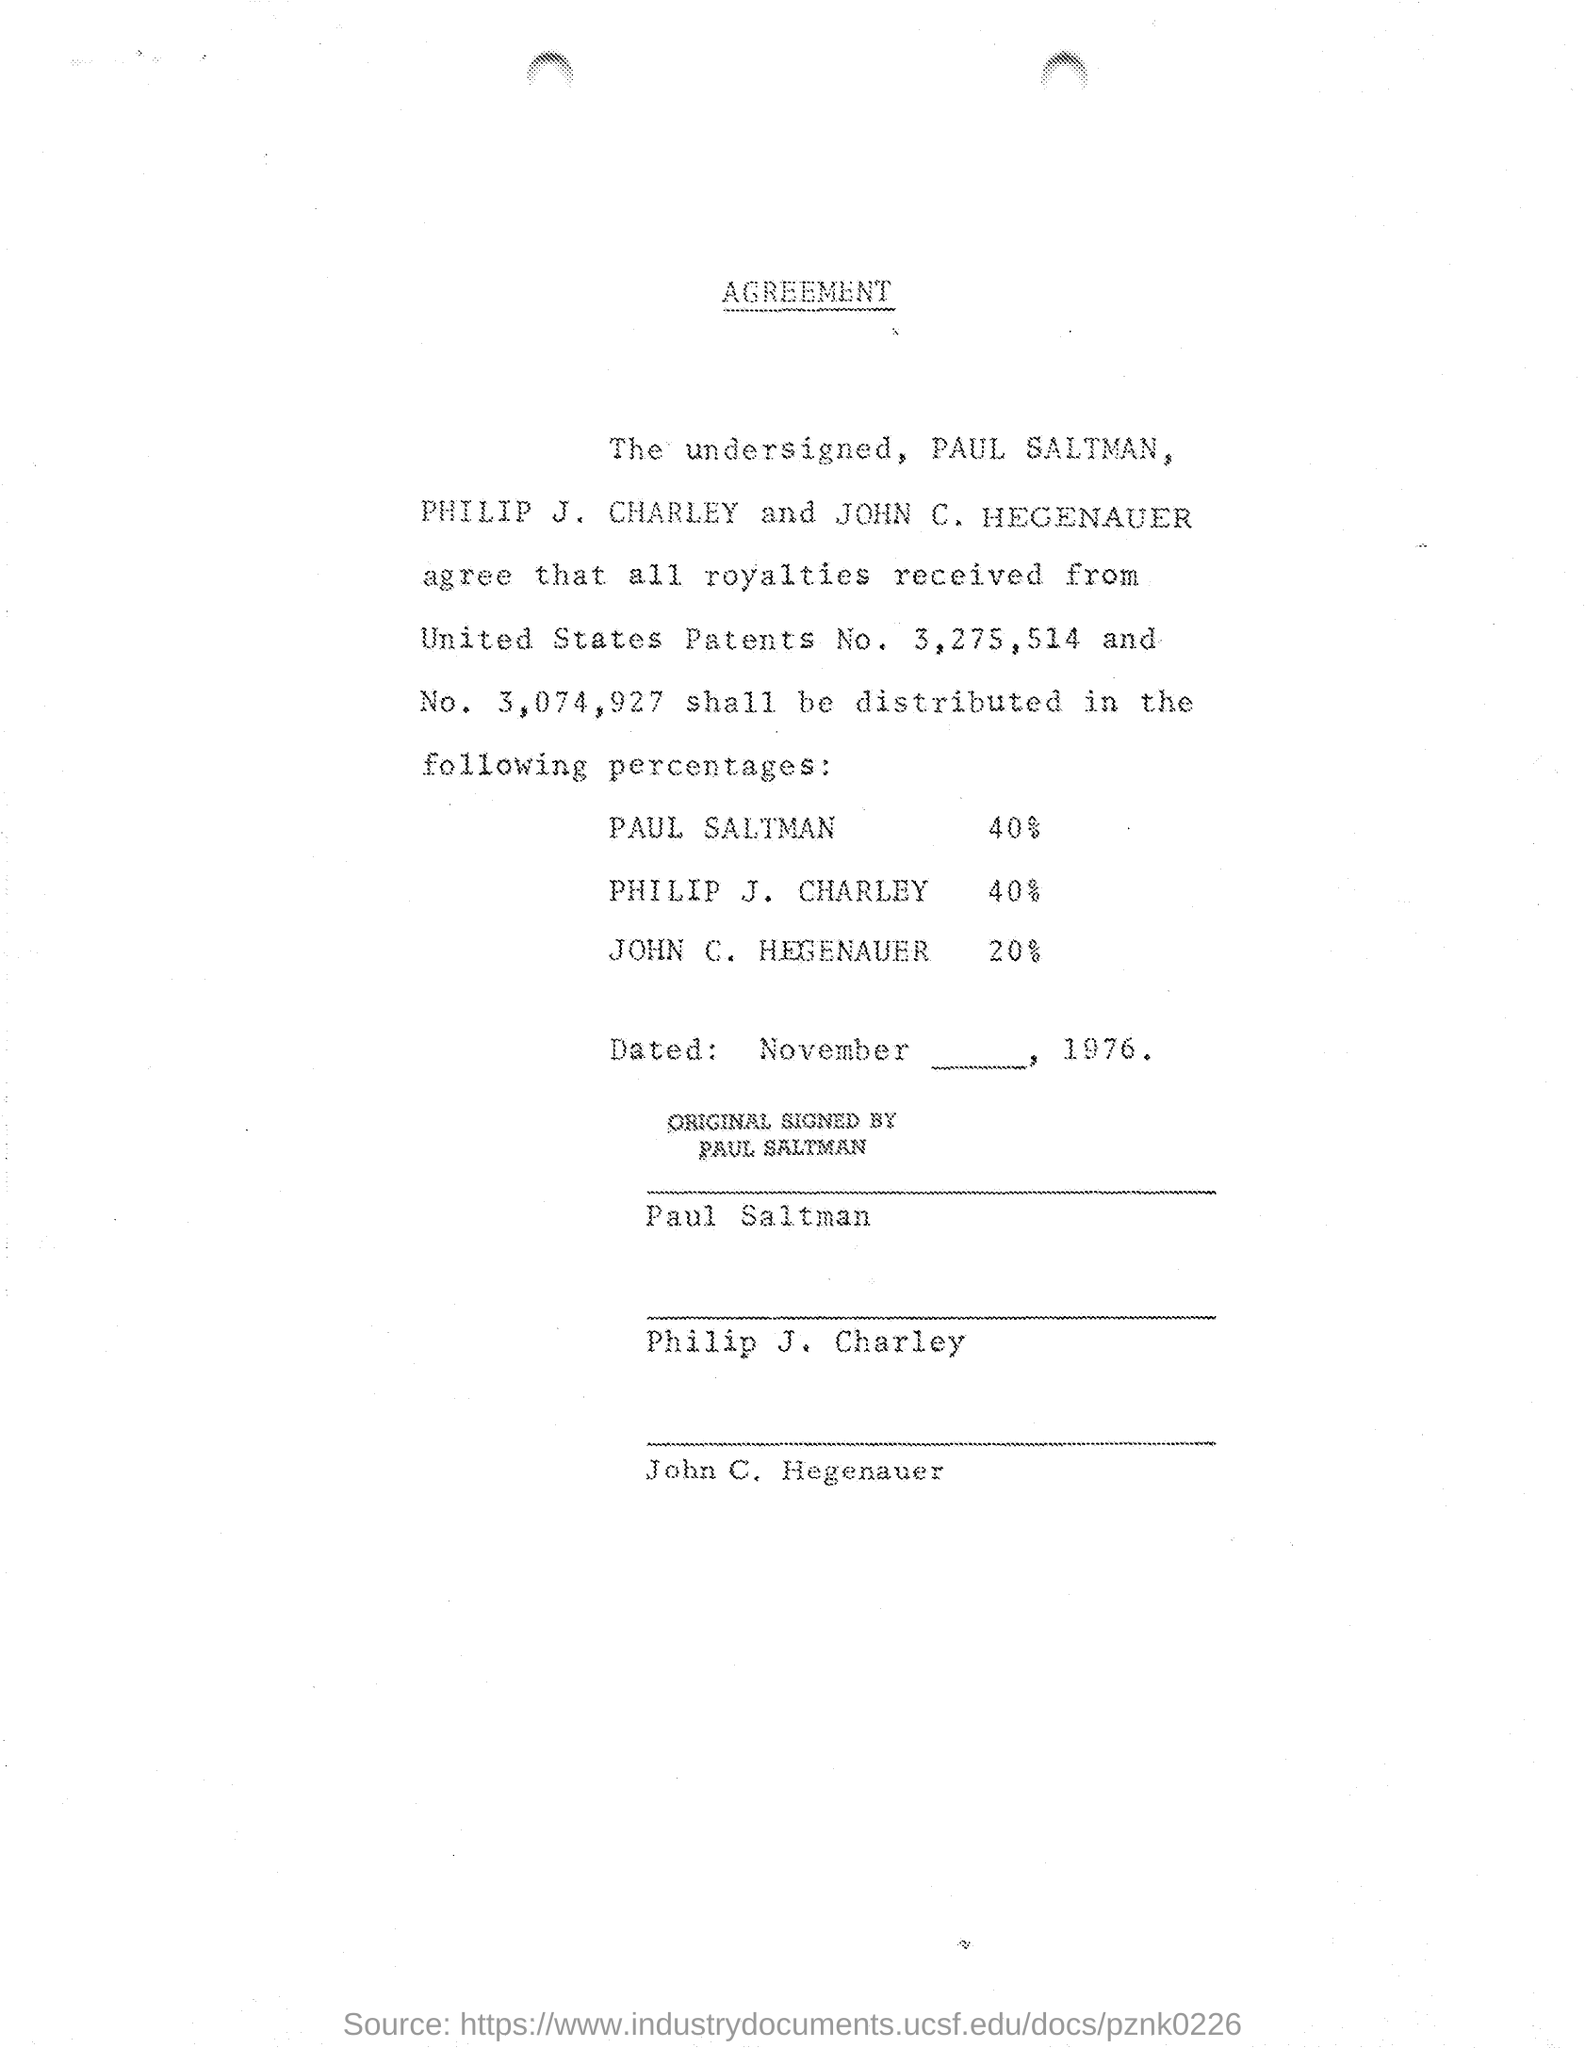Point out several critical features in this image. According to the document, Philip J. Charley is entitled to a royalty of 40%. The document states that Paul Saltman is to receive 40% of the royalty. According to the document, John C. Hegenauer is entitled to a royalty of 20% 